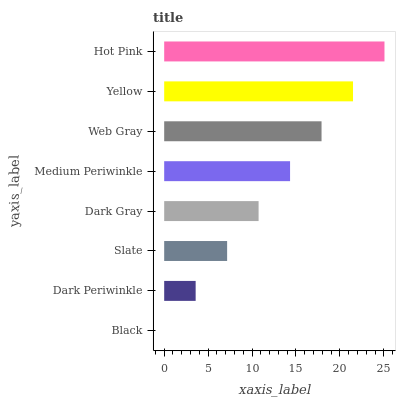Is Black the minimum?
Answer yes or no. Yes. Is Hot Pink the maximum?
Answer yes or no. Yes. Is Dark Periwinkle the minimum?
Answer yes or no. No. Is Dark Periwinkle the maximum?
Answer yes or no. No. Is Dark Periwinkle greater than Black?
Answer yes or no. Yes. Is Black less than Dark Periwinkle?
Answer yes or no. Yes. Is Black greater than Dark Periwinkle?
Answer yes or no. No. Is Dark Periwinkle less than Black?
Answer yes or no. No. Is Medium Periwinkle the high median?
Answer yes or no. Yes. Is Dark Gray the low median?
Answer yes or no. Yes. Is Black the high median?
Answer yes or no. No. Is Web Gray the low median?
Answer yes or no. No. 